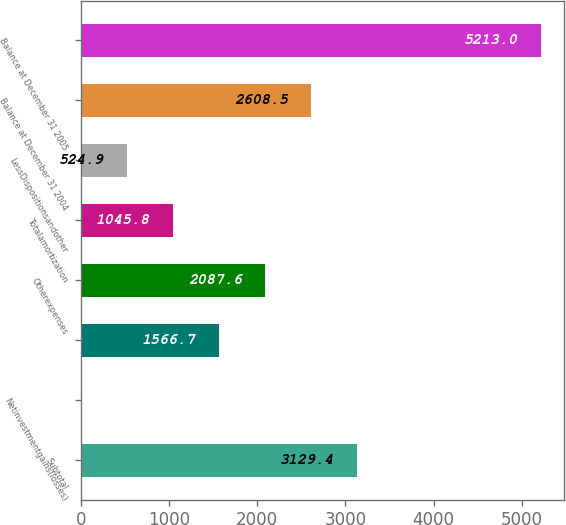Convert chart to OTSL. <chart><loc_0><loc_0><loc_500><loc_500><bar_chart><fcel>Subtotal<fcel>Netinvestmentgains(losses)<fcel>Unnamed: 2<fcel>Otherexpenses<fcel>Totalamortization<fcel>LessDispositionsandother<fcel>Balance at December 31 2004<fcel>Balance at December 31 2005<nl><fcel>3129.4<fcel>4<fcel>1566.7<fcel>2087.6<fcel>1045.8<fcel>524.9<fcel>2608.5<fcel>5213<nl></chart> 